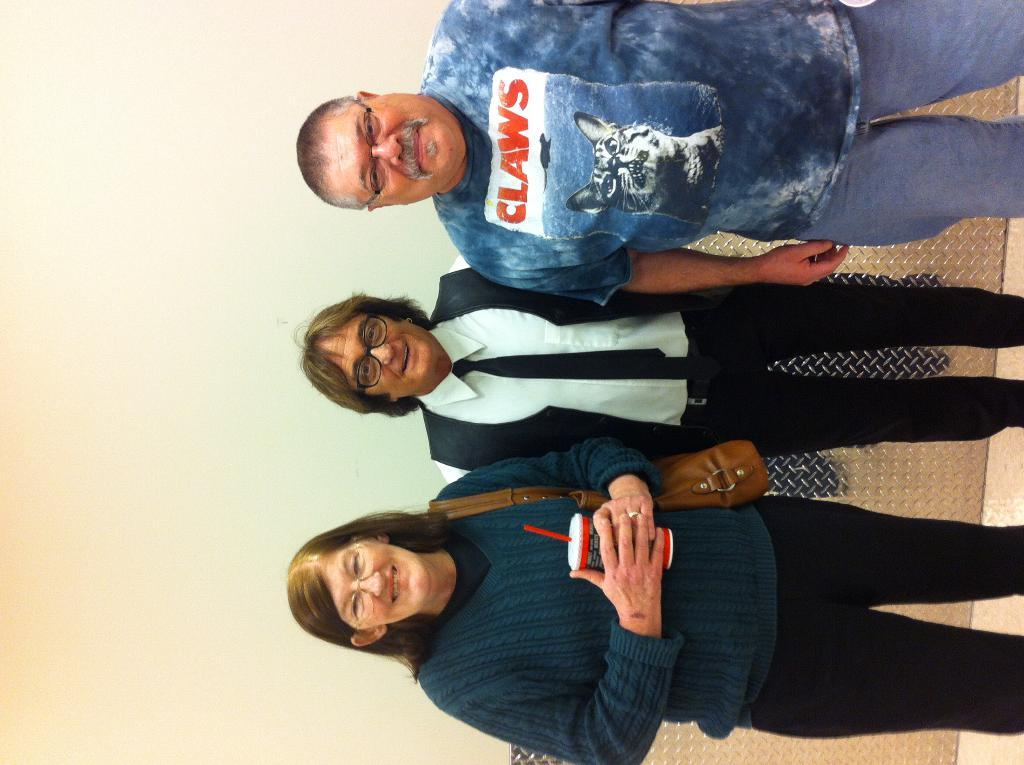What can be seen in the image? There are people standing in the image. What is the background of the image? There is a wall in the image. What type of throat condition can be seen in the image? There is no throat condition present in the image; it features people standing in front of a wall. What kind of road is visible in the image? There is no road visible in the image; it only shows people standing in front of a wall. 